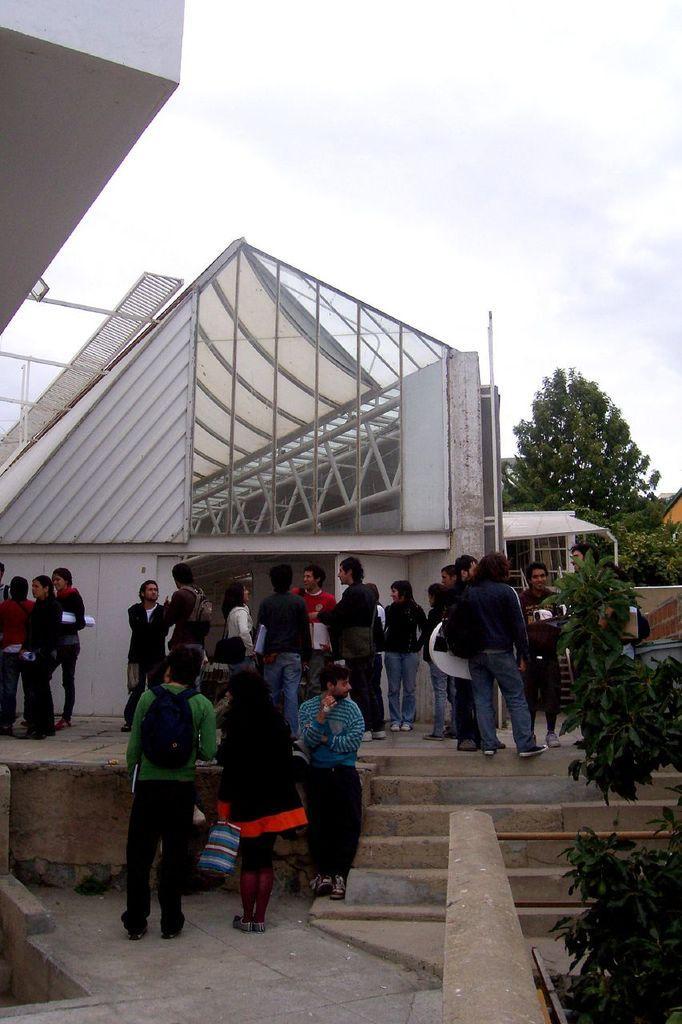How would you summarize this image in a sentence or two? In the picture there are many people standing in front of some architecture and on the right side there are few trees and plants. 